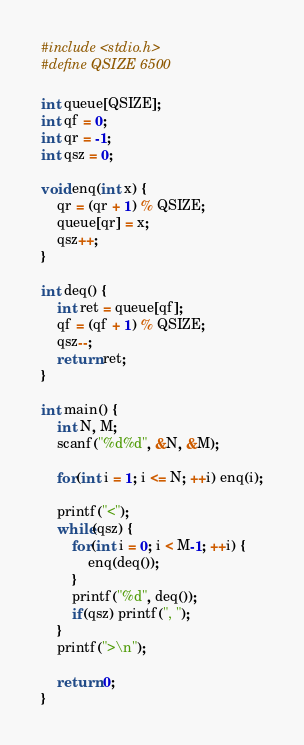<code> <loc_0><loc_0><loc_500><loc_500><_C++_>#include <stdio.h>
#define QSIZE 6500

int queue[QSIZE];
int qf = 0;
int qr = -1;
int qsz = 0;

void enq(int x) {
    qr = (qr + 1) % QSIZE;
    queue[qr] = x;
    qsz++;
}

int deq() {
    int ret = queue[qf];
    qf = (qf + 1) % QSIZE;
    qsz--;
    return ret;
}

int main() {
    int N, M;
    scanf("%d%d", &N, &M);
    
    for(int i = 1; i <= N; ++i) enq(i);
    
    printf("<");
    while(qsz) {
        for(int i = 0; i < M-1; ++i) {
            enq(deq());
        }
        printf("%d", deq());
        if(qsz) printf(", ");
    }
    printf(">\n");
    
    return 0;
}
</code> 